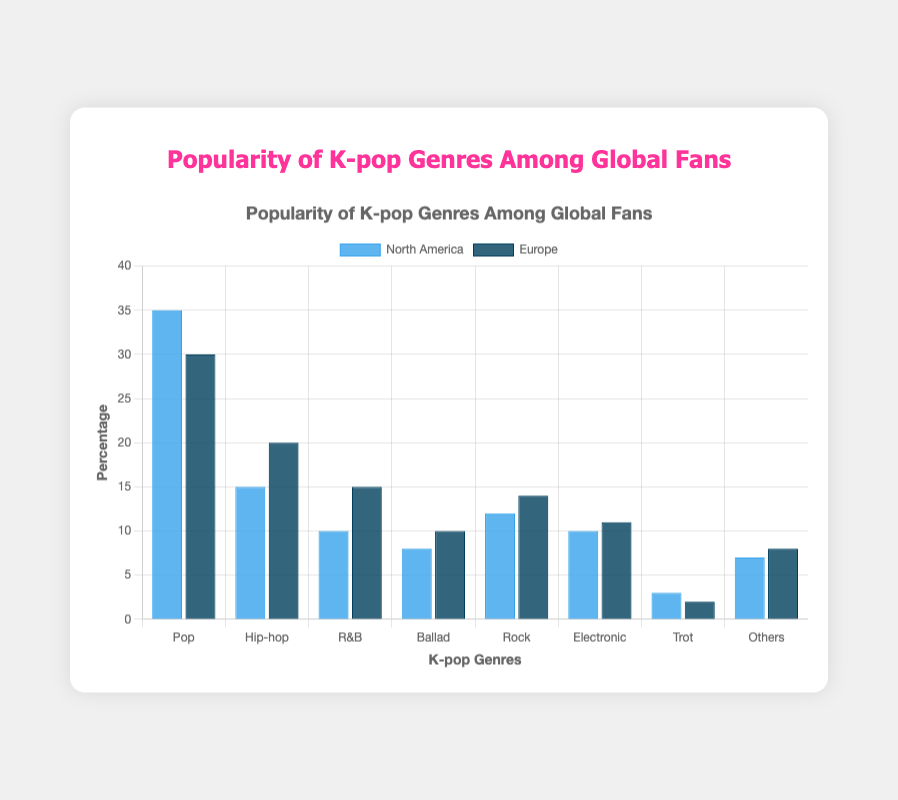Which genre is the most popular in North America? Visually, the bar representing the percentage of Pop in North America is the tallest among all North American bars.
Answer: Pop Which genre has the smallest difference in popularity between North America and Europe? The Ballad genre has percentages of 8% in North America and 10% in Europe, resulting in a difference of 2%, which is the smallest difference compared to other genres.
Answer: Ballad Which region has a higher preference for Hip-hop, North America or Europe? By comparing the height of the bars representing Hip-hop, it is clear that the bar for Europe is taller than the bar for North America.
Answer: Europe What's the total percentage of fans for Electronic and Rock genres in Europe? The percentages for Electronic and Rock in Europe are 11% and 14%, respectively. Adding them gives 11 + 14 = 25%.
Answer: 25% Which genre is the least popular in Europe? The Trot genre has the shortest bar in the Europe region compared to other genres.
Answer: Trot In terms of percentage, how much more popular is Pop in North America compared to Europe? Pop has a percentage of 35% in North America and 30% in Europe. So, it is 35 - 30 = 5% more popular in North America compared to Europe.
Answer: 5% Which genre has the closest popularity percentages between North America and Europe and what are those percentages? Ballad has percentages of 8% in North America and 10% in Europe, which are close to each other with a difference of 2%.
Answer: Ballad, 8% North America, 10% Europe What's the average popularity percentage of R&B across both regions? The percentages for R&B are 10% in North America and 15% in Europe. The average is (10 + 15) / 2 = 12.5%.
Answer: 12.5% Are there any genres where the difference in popularity between North America and Europe is exactly 5%? If so, which one(s)? Comparing the differences, Pop has a difference of 5% (35% in North America and 30% in Europe).
Answer: Pop 